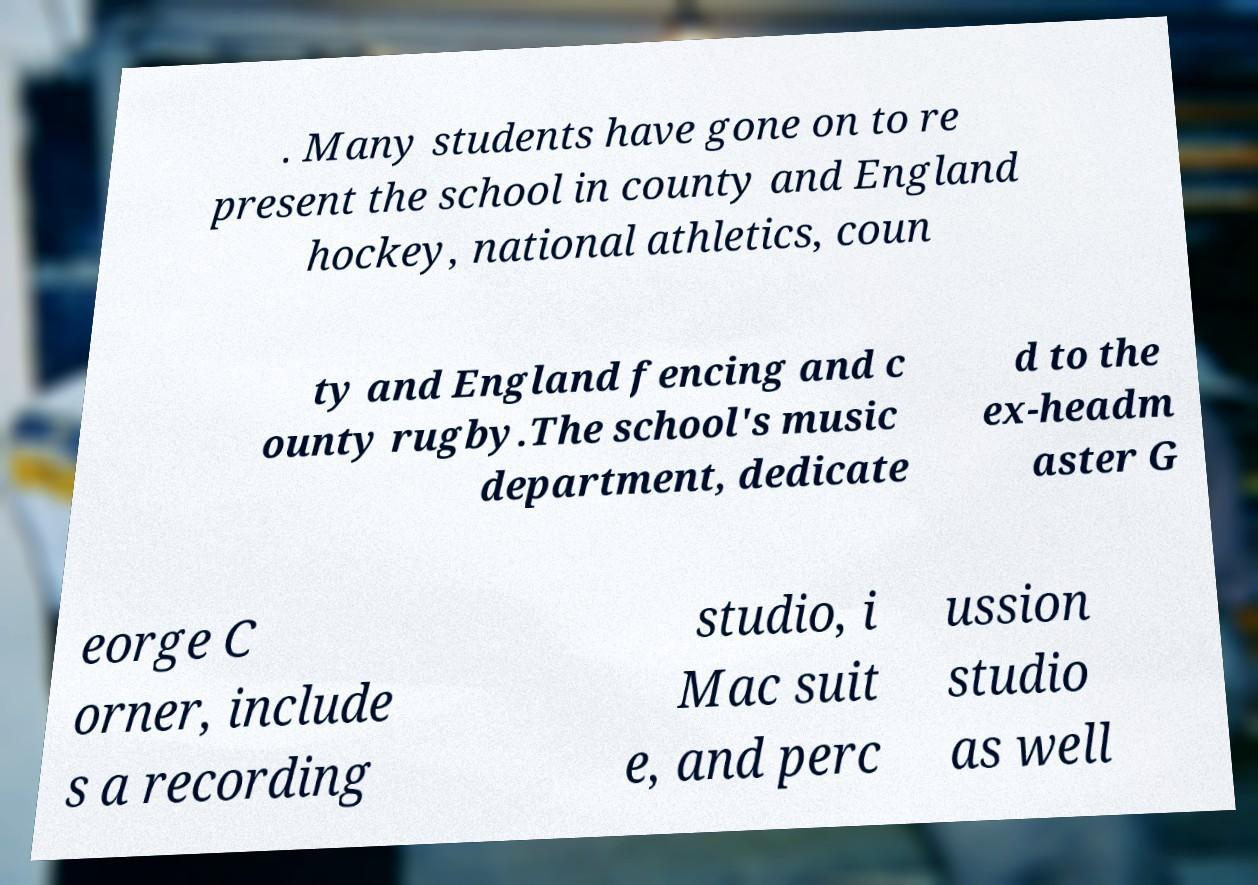Could you extract and type out the text from this image? . Many students have gone on to re present the school in county and England hockey, national athletics, coun ty and England fencing and c ounty rugby.The school's music department, dedicate d to the ex-headm aster G eorge C orner, include s a recording studio, i Mac suit e, and perc ussion studio as well 